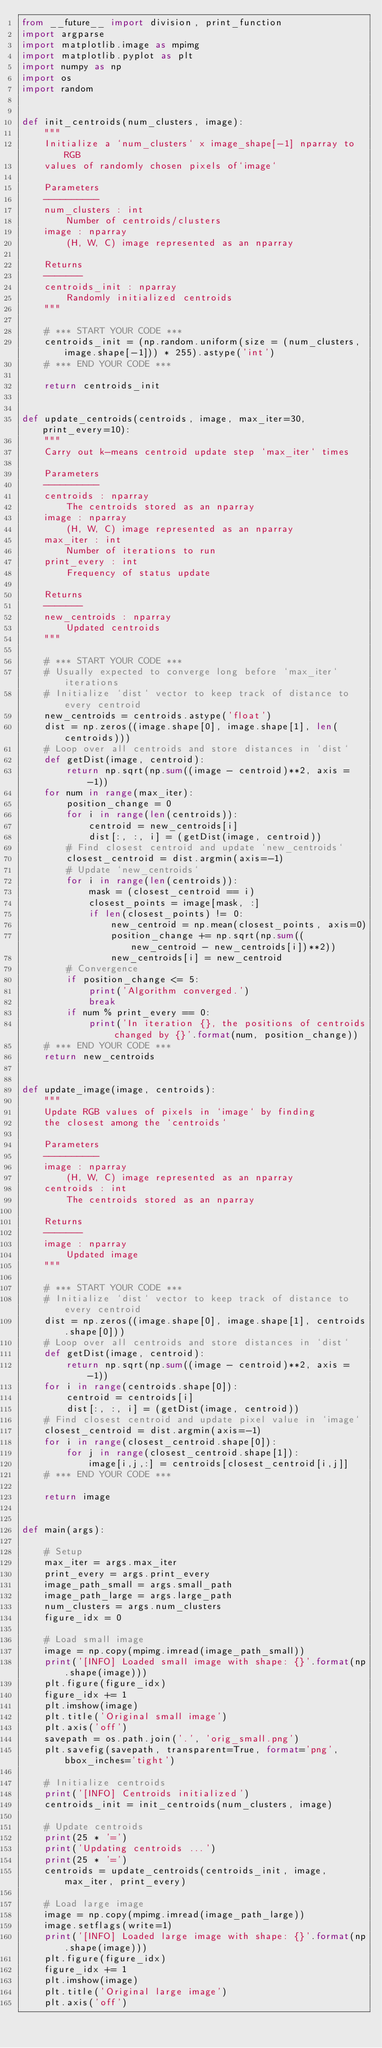Convert code to text. <code><loc_0><loc_0><loc_500><loc_500><_Python_>from __future__ import division, print_function
import argparse
import matplotlib.image as mpimg
import matplotlib.pyplot as plt
import numpy as np
import os
import random


def init_centroids(num_clusters, image):
    """
    Initialize a `num_clusters` x image_shape[-1] nparray to RGB
    values of randomly chosen pixels of`image`

    Parameters
    ----------
    num_clusters : int
        Number of centroids/clusters
    image : nparray
        (H, W, C) image represented as an nparray

    Returns
    -------
    centroids_init : nparray
        Randomly initialized centroids
    """

    # *** START YOUR CODE ***
    centroids_init = (np.random.uniform(size = (num_clusters, image.shape[-1])) * 255).astype('int')
    # *** END YOUR CODE ***

    return centroids_init


def update_centroids(centroids, image, max_iter=30, print_every=10):
    """
    Carry out k-means centroid update step `max_iter` times

    Parameters
    ----------
    centroids : nparray
        The centroids stored as an nparray
    image : nparray
        (H, W, C) image represented as an nparray
    max_iter : int
        Number of iterations to run
    print_every : int
        Frequency of status update

    Returns
    -------
    new_centroids : nparray
        Updated centroids
    """

    # *** START YOUR CODE ***
    # Usually expected to converge long before `max_iter` iterations
    # Initialize `dist` vector to keep track of distance to every centroid
    new_centroids = centroids.astype('float')
    dist = np.zeros((image.shape[0], image.shape[1], len(centroids)))
    # Loop over all centroids and store distances in `dist`
    def getDist(image, centroid):
        return np.sqrt(np.sum((image - centroid)**2, axis = -1))
    for num in range(max_iter):
        position_change = 0
        for i in range(len(centroids)):
            centroid = new_centroids[i]
            dist[:, :, i] = (getDist(image, centroid))
        # Find closest centroid and update `new_centroids`
        closest_centroid = dist.argmin(axis=-1)
        # Update `new_centroids`
        for i in range(len(centroids)):
            mask = (closest_centroid == i)
            closest_points = image[mask, :]
            if len(closest_points) != 0:
                new_centroid = np.mean(closest_points, axis=0)
                position_change += np.sqrt(np.sum((new_centroid - new_centroids[i])**2))
                new_centroids[i] = new_centroid
        # Convergence
        if position_change <= 5:
            print('Algorithm converged.')
            break
        if num % print_every == 0:
            print('In iteration {}, the positions of centroids changed by {}'.format(num, position_change))
    # *** END YOUR CODE ***
    return new_centroids


def update_image(image, centroids):
    """
    Update RGB values of pixels in `image` by finding
    the closest among the `centroids`

    Parameters
    ----------
    image : nparray
        (H, W, C) image represented as an nparray
    centroids : int
        The centroids stored as an nparray

    Returns
    -------
    image : nparray
        Updated image
    """

    # *** START YOUR CODE ***
    # Initialize `dist` vector to keep track of distance to every centroid
    dist = np.zeros((image.shape[0], image.shape[1], centroids.shape[0]))
    # Loop over all centroids and store distances in `dist`
    def getDist(image, centroid):
        return np.sqrt(np.sum((image - centroid)**2, axis = -1))
    for i in range(centroids.shape[0]):
        centroid = centroids[i]
        dist[:, :, i] = (getDist(image, centroid))
    # Find closest centroid and update pixel value in `image`
    closest_centroid = dist.argmin(axis=-1)
    for i in range(closest_centroid.shape[0]):
        for j in range(closest_centroid.shape[1]):
            image[i,j,:] = centroids[closest_centroid[i,j]]
    # *** END YOUR CODE ***

    return image


def main(args):

    # Setup
    max_iter = args.max_iter
    print_every = args.print_every
    image_path_small = args.small_path
    image_path_large = args.large_path
    num_clusters = args.num_clusters
    figure_idx = 0

    # Load small image
    image = np.copy(mpimg.imread(image_path_small))
    print('[INFO] Loaded small image with shape: {}'.format(np.shape(image)))
    plt.figure(figure_idx)
    figure_idx += 1
    plt.imshow(image)
    plt.title('Original small image')
    plt.axis('off')
    savepath = os.path.join('.', 'orig_small.png')
    plt.savefig(savepath, transparent=True, format='png', bbox_inches='tight')

    # Initialize centroids
    print('[INFO] Centroids initialized')
    centroids_init = init_centroids(num_clusters, image)

    # Update centroids
    print(25 * '=')
    print('Updating centroids ...')
    print(25 * '=')
    centroids = update_centroids(centroids_init, image, max_iter, print_every)

    # Load large image
    image = np.copy(mpimg.imread(image_path_large))
    image.setflags(write=1)
    print('[INFO] Loaded large image with shape: {}'.format(np.shape(image)))
    plt.figure(figure_idx)
    figure_idx += 1
    plt.imshow(image)
    plt.title('Original large image')
    plt.axis('off')</code> 